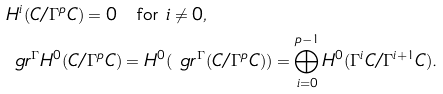<formula> <loc_0><loc_0><loc_500><loc_500>& H ^ { i } ( C / \Gamma ^ { p } C ) = 0 \quad \text {for $i\ne 0$} , \\ & \ g r ^ { \Gamma } H ^ { 0 } ( C / \Gamma ^ { p } C ) = H ^ { 0 } ( \ g r ^ { \Gamma } ( C / \Gamma ^ { p } C ) ) = \bigoplus _ { i = 0 } ^ { p - 1 } H ^ { 0 } ( \Gamma ^ { i } C / \Gamma ^ { i + 1 } C ) .</formula> 